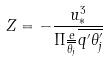<formula> <loc_0><loc_0><loc_500><loc_500>Z = - \frac { u _ { * } ^ { 3 } } { \Pi \frac { e } { \overline { \theta _ { j } } } \overline { q ^ { \prime } \theta _ { j } ^ { \prime } } }</formula> 